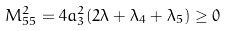Convert formula to latex. <formula><loc_0><loc_0><loc_500><loc_500>M _ { 5 5 } ^ { 2 } = 4 a _ { 3 } ^ { 2 } ( 2 \lambda + \lambda _ { 4 } + \lambda _ { 5 } ) \geq 0</formula> 